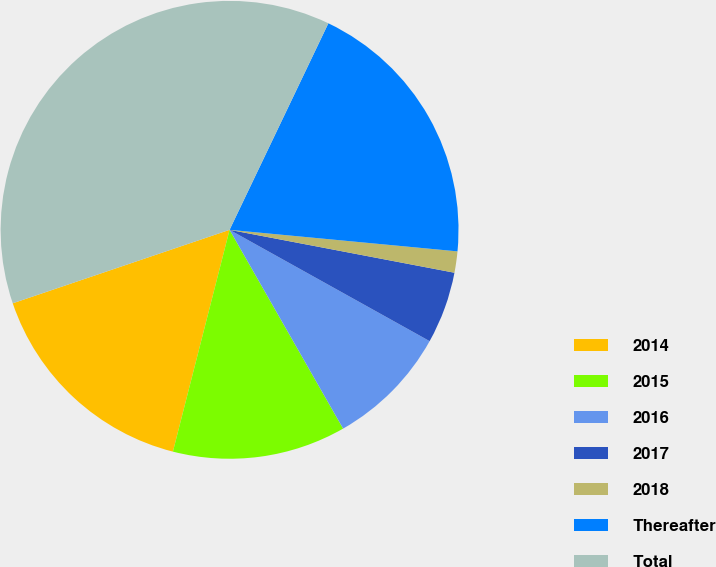Convert chart. <chart><loc_0><loc_0><loc_500><loc_500><pie_chart><fcel>2014<fcel>2015<fcel>2016<fcel>2017<fcel>2018<fcel>Thereafter<fcel>Total<nl><fcel>15.82%<fcel>12.24%<fcel>8.66%<fcel>5.08%<fcel>1.5%<fcel>19.4%<fcel>37.3%<nl></chart> 